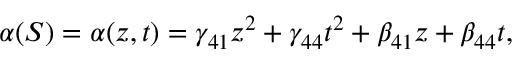<formula> <loc_0><loc_0><loc_500><loc_500>\alpha ( S ) = \alpha ( z , t ) = \gamma _ { 4 1 } z ^ { 2 } + \gamma _ { 4 4 } t ^ { 2 } + \beta _ { 4 1 } z + \beta _ { 4 4 } t ,</formula> 